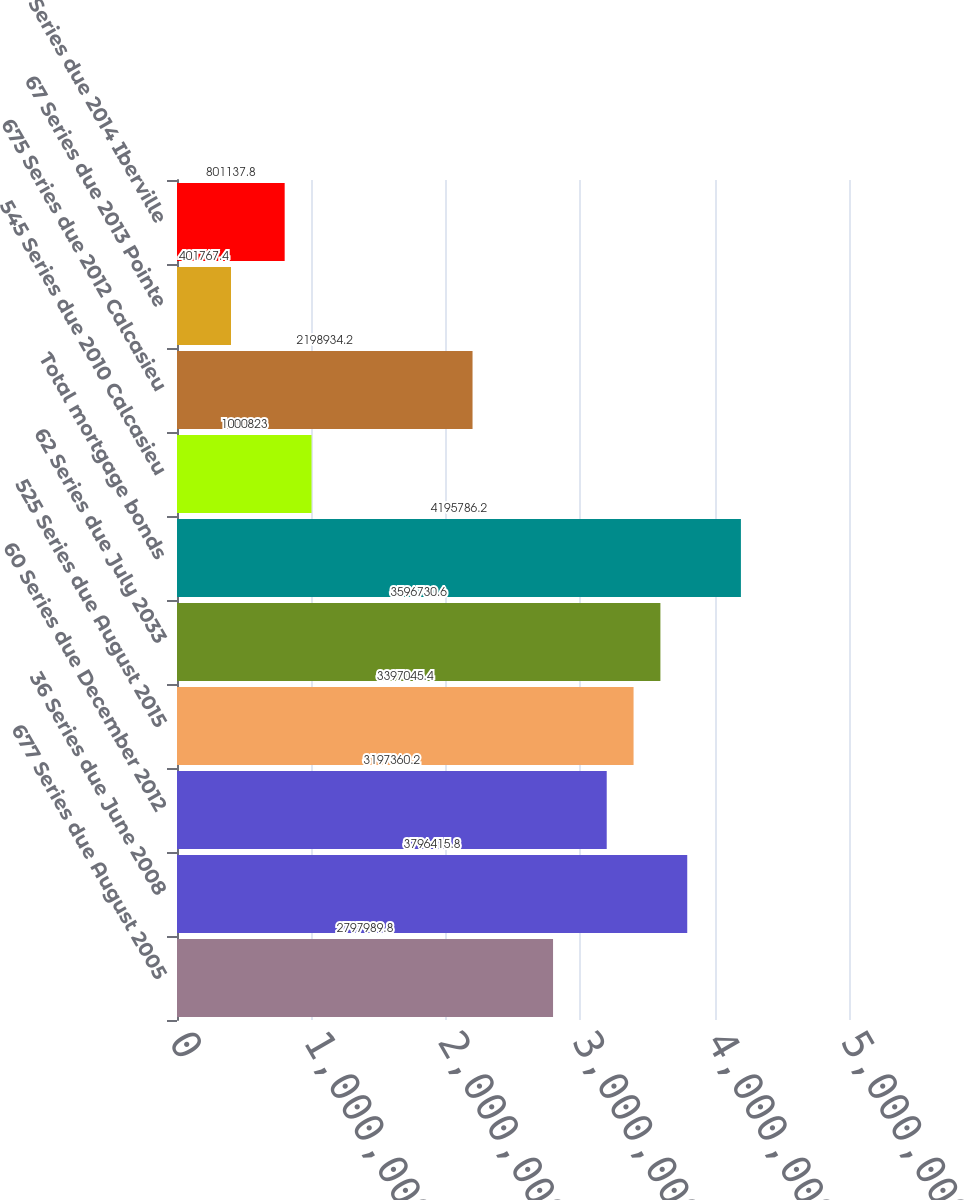Convert chart. <chart><loc_0><loc_0><loc_500><loc_500><bar_chart><fcel>677 Series due August 2005<fcel>36 Series due June 2008<fcel>60 Series due December 2012<fcel>525 Series due August 2015<fcel>62 Series due July 2033<fcel>Total mortgage bonds<fcel>545 Series due 2010 Calcasieu<fcel>675 Series due 2012 Calcasieu<fcel>67 Series due 2013 Pointe<fcel>57 Series due 2014 Iberville<nl><fcel>2.79799e+06<fcel>3.79642e+06<fcel>3.19736e+06<fcel>3.39705e+06<fcel>3.59673e+06<fcel>4.19579e+06<fcel>1.00082e+06<fcel>2.19893e+06<fcel>401767<fcel>801138<nl></chart> 